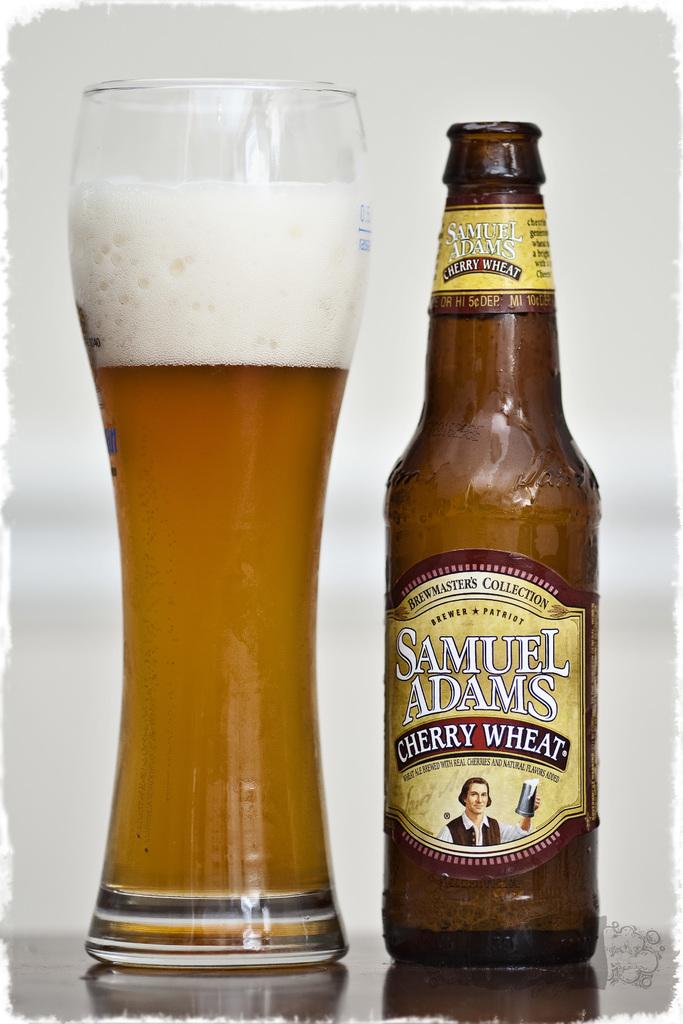What type of beer is it?
Make the answer very short. Cherry wheat. 